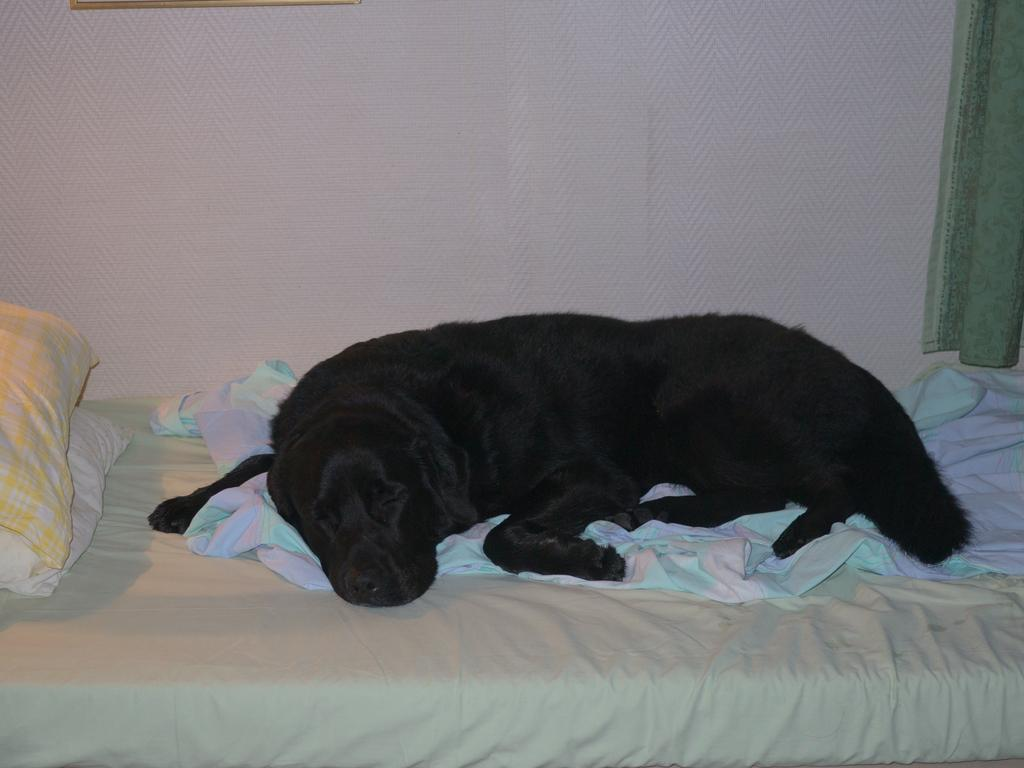What is the dog doing in the image? The dog is lying on the bed in the image. What is the dog using for comfort? The dog has a blanket and pillows in the image. What can be seen on the right side of the image? There is a curtain on the right side of the image. What is attached to the wall at the top of the image? There is a frame attached to the wall at the top of the image. How does the dog care for its knot in the image? There is no knot present in the image, as it features a dog lying on a bed with a blanket and pillows. 